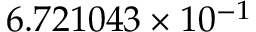<formula> <loc_0><loc_0><loc_500><loc_500>6 . 7 2 1 0 4 3 \times 1 0 ^ { - 1 }</formula> 